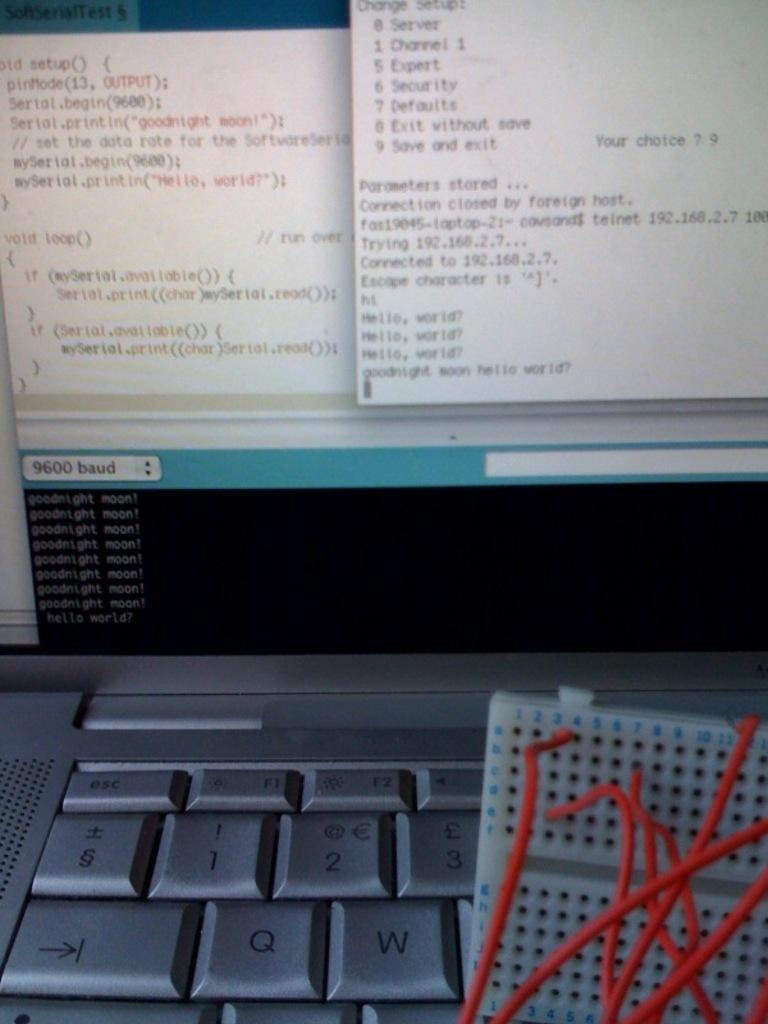Provide a one-sentence caption for the provided image. a computer that has 'goodnight moon!' on one of its open tabs over and over again. 